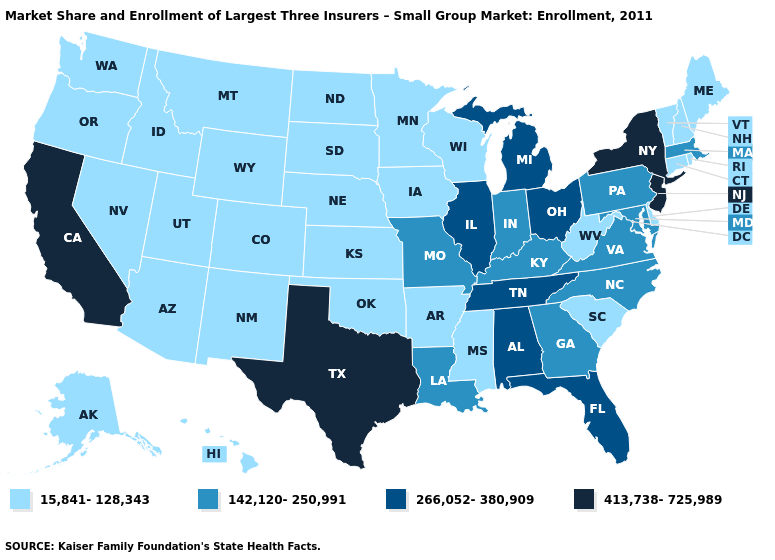Name the states that have a value in the range 15,841-128,343?
Concise answer only. Alaska, Arizona, Arkansas, Colorado, Connecticut, Delaware, Hawaii, Idaho, Iowa, Kansas, Maine, Minnesota, Mississippi, Montana, Nebraska, Nevada, New Hampshire, New Mexico, North Dakota, Oklahoma, Oregon, Rhode Island, South Carolina, South Dakota, Utah, Vermont, Washington, West Virginia, Wisconsin, Wyoming. Which states have the highest value in the USA?
Short answer required. California, New Jersey, New York, Texas. Does the first symbol in the legend represent the smallest category?
Keep it brief. Yes. Name the states that have a value in the range 266,052-380,909?
Concise answer only. Alabama, Florida, Illinois, Michigan, Ohio, Tennessee. What is the lowest value in states that border Georgia?
Quick response, please. 15,841-128,343. Among the states that border North Carolina , does Georgia have the lowest value?
Concise answer only. No. What is the lowest value in the MidWest?
Short answer required. 15,841-128,343. What is the lowest value in states that border California?
Keep it brief. 15,841-128,343. Among the states that border South Dakota , which have the lowest value?
Quick response, please. Iowa, Minnesota, Montana, Nebraska, North Dakota, Wyoming. Name the states that have a value in the range 413,738-725,989?
Keep it brief. California, New Jersey, New York, Texas. Name the states that have a value in the range 142,120-250,991?
Concise answer only. Georgia, Indiana, Kentucky, Louisiana, Maryland, Massachusetts, Missouri, North Carolina, Pennsylvania, Virginia. What is the highest value in the South ?
Short answer required. 413,738-725,989. Does Michigan have the lowest value in the MidWest?
Write a very short answer. No. Does New York have a higher value than California?
Write a very short answer. No. What is the value of New Hampshire?
Answer briefly. 15,841-128,343. 